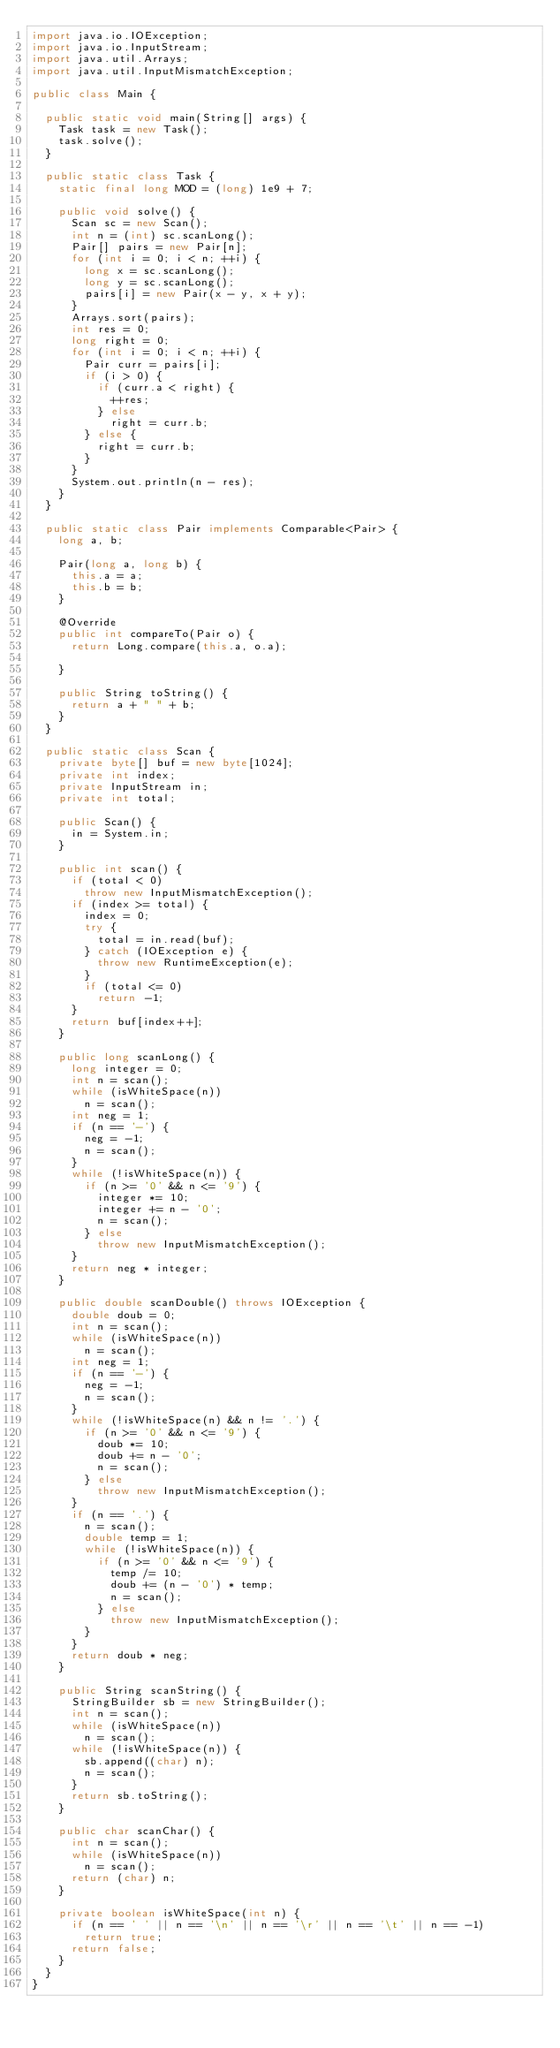<code> <loc_0><loc_0><loc_500><loc_500><_Java_>import java.io.IOException;
import java.io.InputStream;
import java.util.Arrays;
import java.util.InputMismatchException;

public class Main {

	public static void main(String[] args) {
		Task task = new Task();
		task.solve();
	}

	public static class Task {
		static final long MOD = (long) 1e9 + 7;

		public void solve() {
			Scan sc = new Scan();
			int n = (int) sc.scanLong();
			Pair[] pairs = new Pair[n];
			for (int i = 0; i < n; ++i) {
				long x = sc.scanLong();
				long y = sc.scanLong();
				pairs[i] = new Pair(x - y, x + y);
			}
			Arrays.sort(pairs);
			int res = 0;
			long right = 0;
			for (int i = 0; i < n; ++i) {
				Pair curr = pairs[i];
				if (i > 0) {
					if (curr.a < right) {
						++res;
					} else
						right = curr.b;
				} else {
					right = curr.b;
				}
			}
			System.out.println(n - res);
		}
	}

	public static class Pair implements Comparable<Pair> {
		long a, b;

		Pair(long a, long b) {
			this.a = a;
			this.b = b;
		}

		@Override
		public int compareTo(Pair o) {
			return Long.compare(this.a, o.a);

		}

		public String toString() {
			return a + " " + b;
		}
	}

	public static class Scan {
		private byte[] buf = new byte[1024];
		private int index;
		private InputStream in;
		private int total;

		public Scan() {
			in = System.in;
		}

		public int scan() {
			if (total < 0)
				throw new InputMismatchException();
			if (index >= total) {
				index = 0;
				try {
					total = in.read(buf);
				} catch (IOException e) {
					throw new RuntimeException(e);
				}
				if (total <= 0)
					return -1;
			}
			return buf[index++];
		}

		public long scanLong() {
			long integer = 0;
			int n = scan();
			while (isWhiteSpace(n))
				n = scan();
			int neg = 1;
			if (n == '-') {
				neg = -1;
				n = scan();
			}
			while (!isWhiteSpace(n)) {
				if (n >= '0' && n <= '9') {
					integer *= 10;
					integer += n - '0';
					n = scan();
				} else
					throw new InputMismatchException();
			}
			return neg * integer;
		}

		public double scanDouble() throws IOException {
			double doub = 0;
			int n = scan();
			while (isWhiteSpace(n))
				n = scan();
			int neg = 1;
			if (n == '-') {
				neg = -1;
				n = scan();
			}
			while (!isWhiteSpace(n) && n != '.') {
				if (n >= '0' && n <= '9') {
					doub *= 10;
					doub += n - '0';
					n = scan();
				} else
					throw new InputMismatchException();
			}
			if (n == '.') {
				n = scan();
				double temp = 1;
				while (!isWhiteSpace(n)) {
					if (n >= '0' && n <= '9') {
						temp /= 10;
						doub += (n - '0') * temp;
						n = scan();
					} else
						throw new InputMismatchException();
				}
			}
			return doub * neg;
		}

		public String scanString() {
			StringBuilder sb = new StringBuilder();
			int n = scan();
			while (isWhiteSpace(n))
				n = scan();
			while (!isWhiteSpace(n)) {
				sb.append((char) n);
				n = scan();
			}
			return sb.toString();
		}

		public char scanChar() {
			int n = scan();
			while (isWhiteSpace(n))
				n = scan();
			return (char) n;
		}

		private boolean isWhiteSpace(int n) {
			if (n == ' ' || n == '\n' || n == '\r' || n == '\t' || n == -1)
				return true;
			return false;
		}
	}
}
</code> 